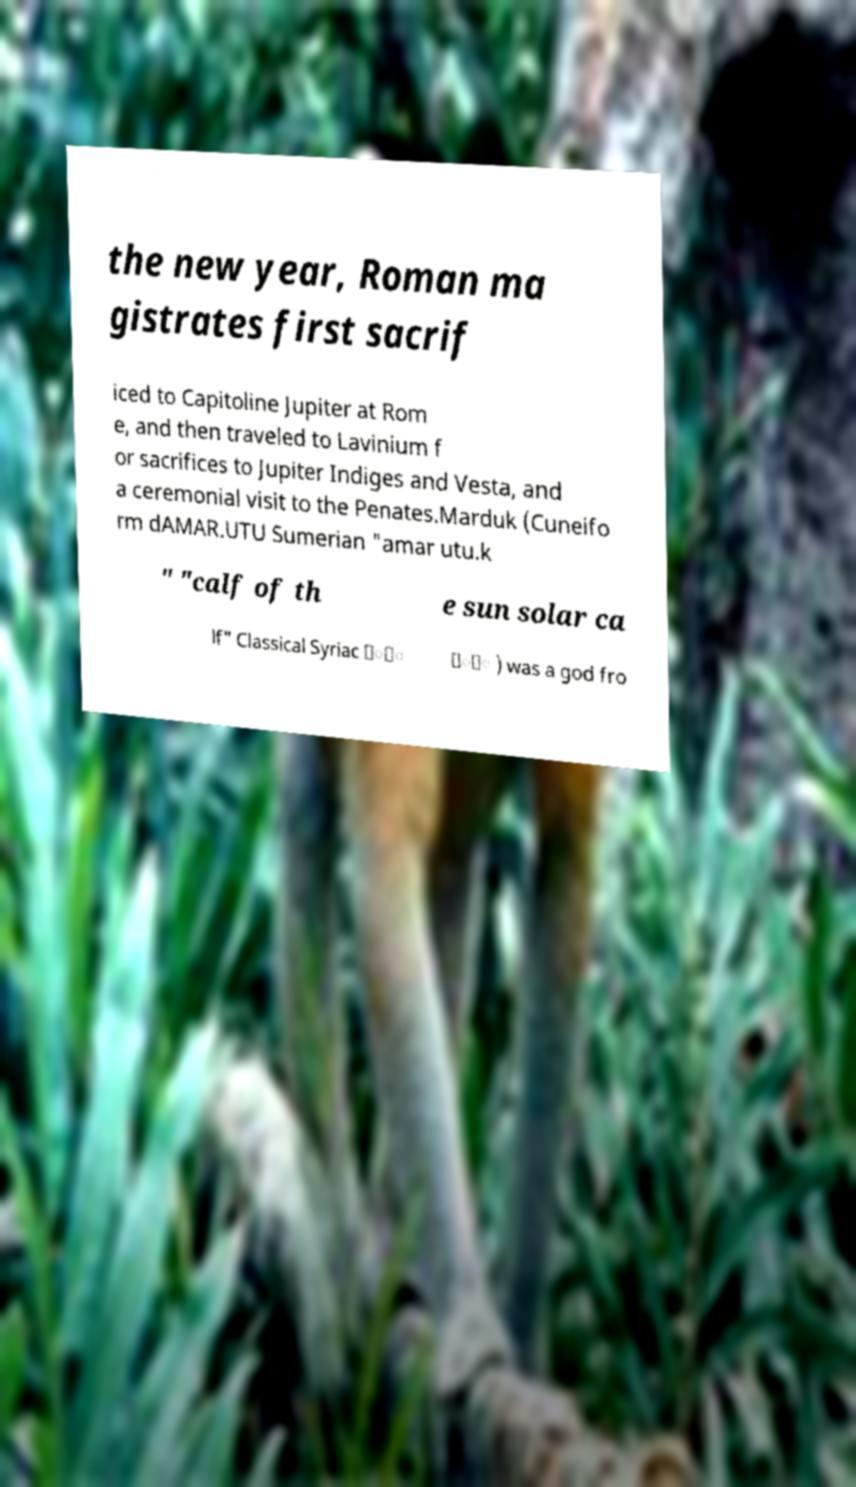Could you extract and type out the text from this image? the new year, Roman ma gistrates first sacrif iced to Capitoline Jupiter at Rom e, and then traveled to Lavinium f or sacrifices to Jupiter Indiges and Vesta, and a ceremonial visit to the Penates.Marduk (Cuneifo rm dAMAR.UTU Sumerian "amar utu.k " "calf of th e sun solar ca lf" Classical Syriac ݂ܿ ܼܵ ) was a god fro 